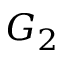Convert formula to latex. <formula><loc_0><loc_0><loc_500><loc_500>G _ { 2 }</formula> 